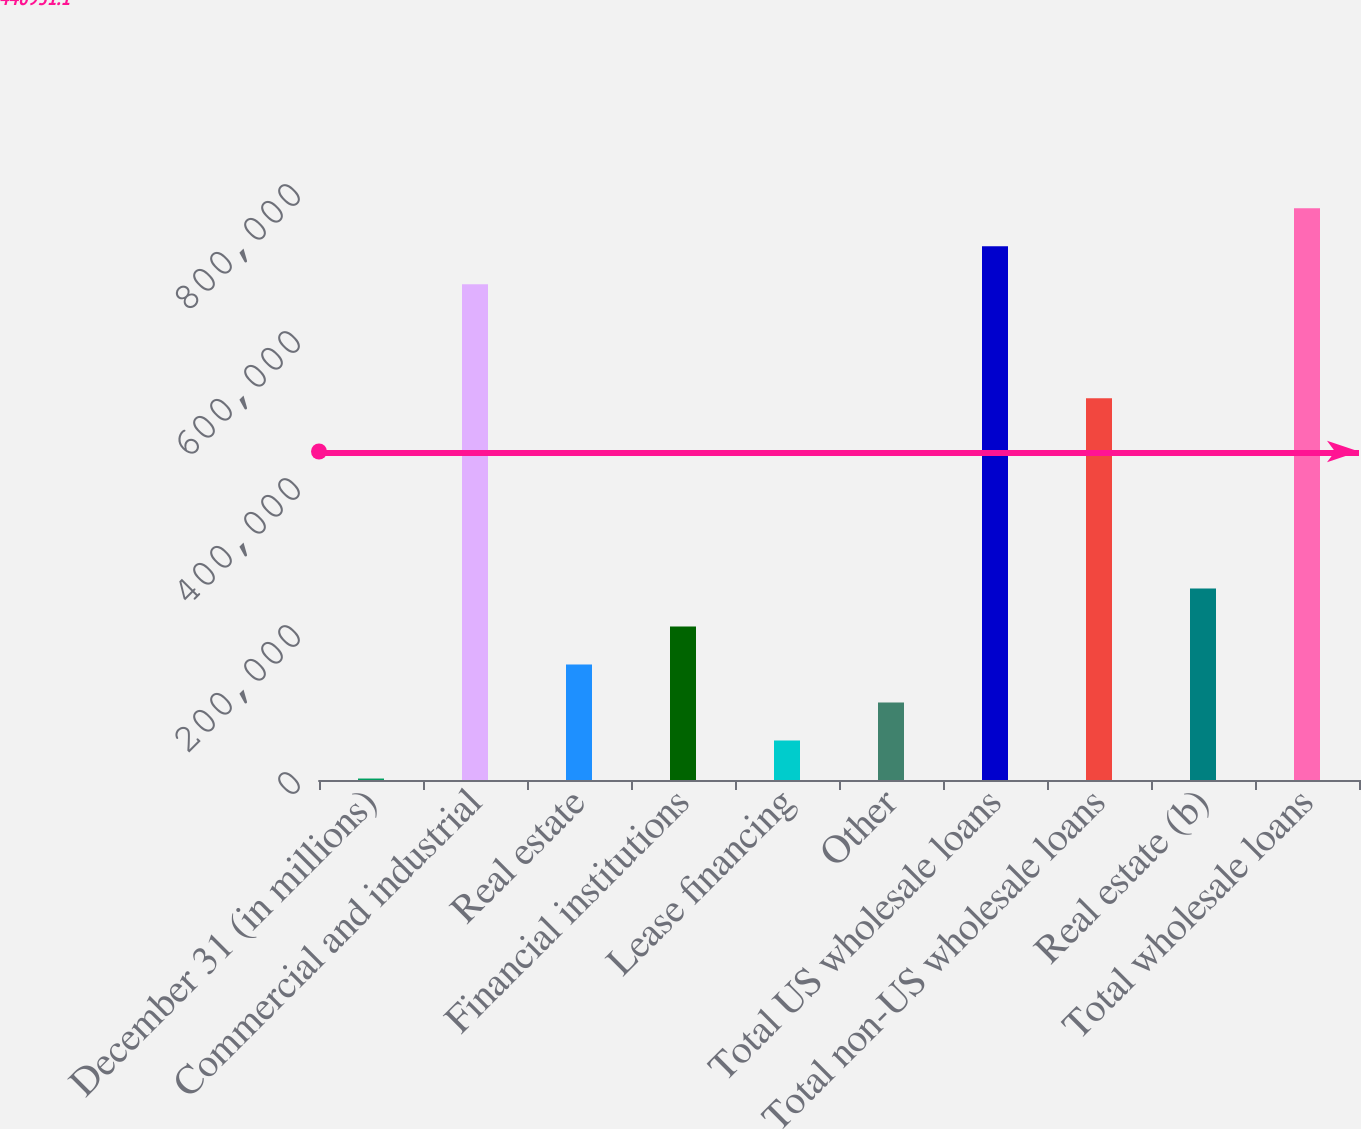Convert chart. <chart><loc_0><loc_0><loc_500><loc_500><bar_chart><fcel>December 31 (in millions)<fcel>Commercial and industrial<fcel>Real estate<fcel>Financial institutions<fcel>Lease financing<fcel>Other<fcel>Total US wholesale loans<fcel>Total non-US wholesale loans<fcel>Real estate (b)<fcel>Total wholesale loans<nl><fcel>2007<fcel>674584<fcel>157217<fcel>208954<fcel>53743.7<fcel>105480<fcel>726321<fcel>519374<fcel>260690<fcel>778058<nl></chart> 